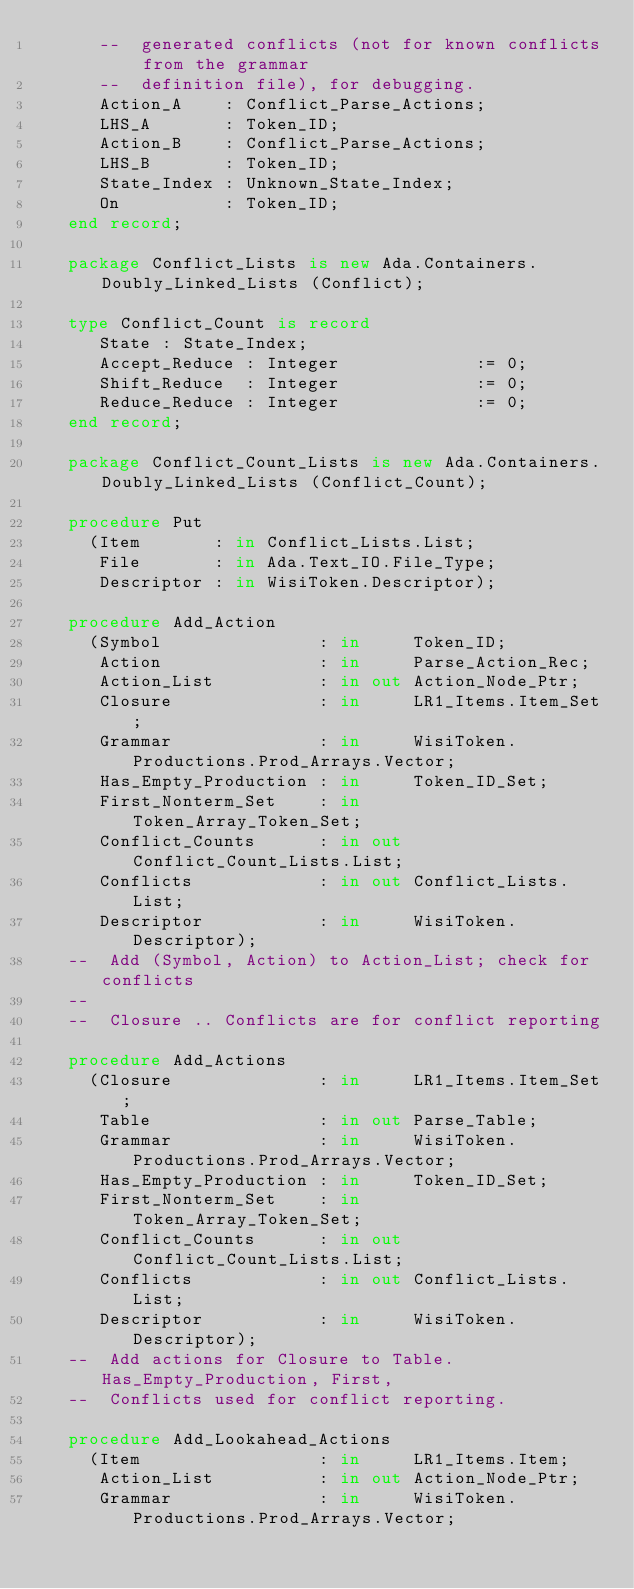Convert code to text. <code><loc_0><loc_0><loc_500><loc_500><_Ada_>      --  generated conflicts (not for known conflicts from the grammar
      --  definition file), for debugging.
      Action_A    : Conflict_Parse_Actions;
      LHS_A       : Token_ID;
      Action_B    : Conflict_Parse_Actions;
      LHS_B       : Token_ID;
      State_Index : Unknown_State_Index;
      On          : Token_ID;
   end record;

   package Conflict_Lists is new Ada.Containers.Doubly_Linked_Lists (Conflict);

   type Conflict_Count is record
      State : State_Index;
      Accept_Reduce : Integer             := 0;
      Shift_Reduce  : Integer             := 0;
      Reduce_Reduce : Integer             := 0;
   end record;

   package Conflict_Count_Lists is new Ada.Containers.Doubly_Linked_Lists (Conflict_Count);

   procedure Put
     (Item       : in Conflict_Lists.List;
      File       : in Ada.Text_IO.File_Type;
      Descriptor : in WisiToken.Descriptor);

   procedure Add_Action
     (Symbol               : in     Token_ID;
      Action               : in     Parse_Action_Rec;
      Action_List          : in out Action_Node_Ptr;
      Closure              : in     LR1_Items.Item_Set;
      Grammar              : in     WisiToken.Productions.Prod_Arrays.Vector;
      Has_Empty_Production : in     Token_ID_Set;
      First_Nonterm_Set    : in     Token_Array_Token_Set;
      Conflict_Counts      : in out Conflict_Count_Lists.List;
      Conflicts            : in out Conflict_Lists.List;
      Descriptor           : in     WisiToken.Descriptor);
   --  Add (Symbol, Action) to Action_List; check for conflicts
   --
   --  Closure .. Conflicts are for conflict reporting

   procedure Add_Actions
     (Closure              : in     LR1_Items.Item_Set;
      Table                : in out Parse_Table;
      Grammar              : in     WisiToken.Productions.Prod_Arrays.Vector;
      Has_Empty_Production : in     Token_ID_Set;
      First_Nonterm_Set    : in     Token_Array_Token_Set;
      Conflict_Counts      : in out Conflict_Count_Lists.List;
      Conflicts            : in out Conflict_Lists.List;
      Descriptor           : in     WisiToken.Descriptor);
   --  Add actions for Closure to Table. Has_Empty_Production, First,
   --  Conflicts used for conflict reporting.

   procedure Add_Lookahead_Actions
     (Item                 : in     LR1_Items.Item;
      Action_List          : in out Action_Node_Ptr;
      Grammar              : in     WisiToken.Productions.Prod_Arrays.Vector;</code> 